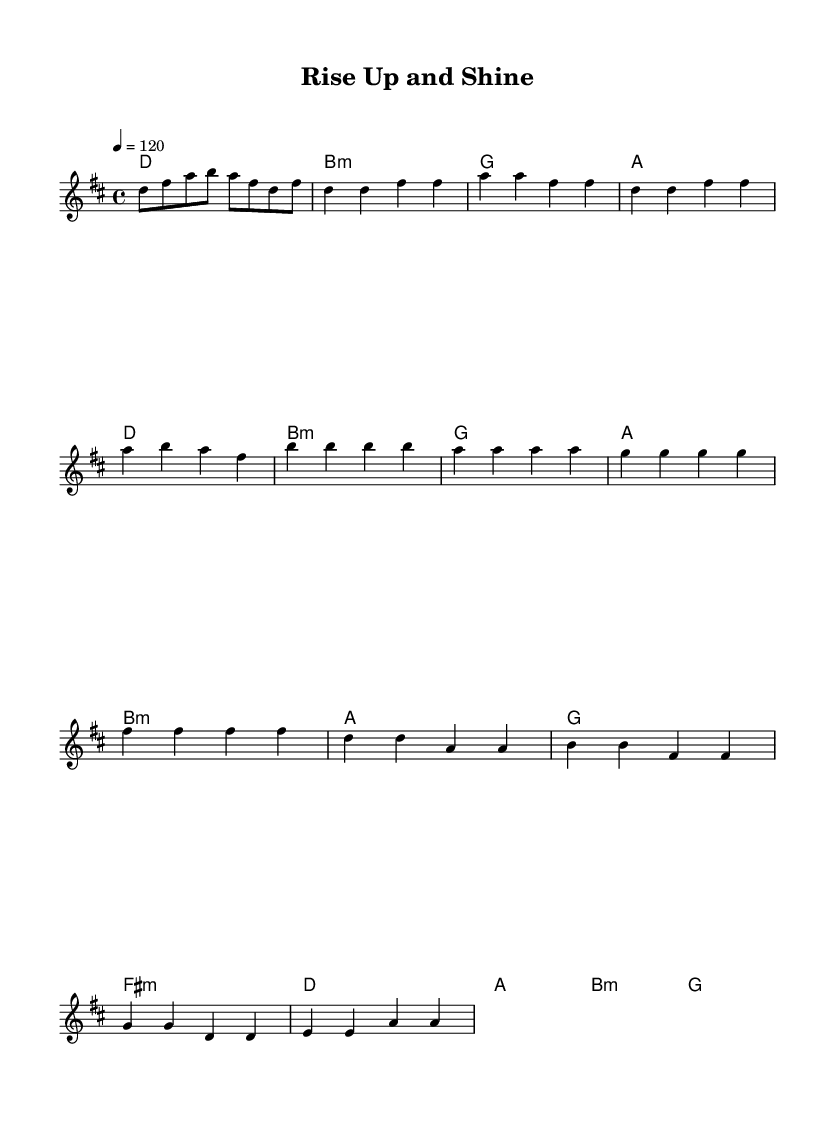What is the key signature of this music? The key signature indicates the key of the piece, which is D major, requiring two sharps (F# and C#).
Answer: D major What is the time signature? The time signature is located at the beginning of the sheet music, indicating the rhythm pattern; in this case, it's 4/4, meaning there are four beats in a measure.
Answer: 4/4 What is the tempo marking? The tempo marking is indicated at the beginning and shows the speed of the music; here, it indicates a tempo of 120 beats per minute.
Answer: 120 What is the first chord of the piece? The first chord is found at the start of the harmony section; the chord is D major.
Answer: D major How many measures are in the chorus section? By counting the specific lines where the chorus is written in the score, there are four measures in this section.
Answer: 4 In which section does the melody ascend to the highest note? Observing the melody, the highest note appears during the pre-chorus section where B is noted, leading to a peak.
Answer: Pre-Chorus What mood does the chord progression convey in the chorus? Analyzing the chord progression of the chorus (D, A, B minor, and G), this combination typically conveys a feeling of uplift and positivity, characteristic of motivational music.
Answer: Uplift 